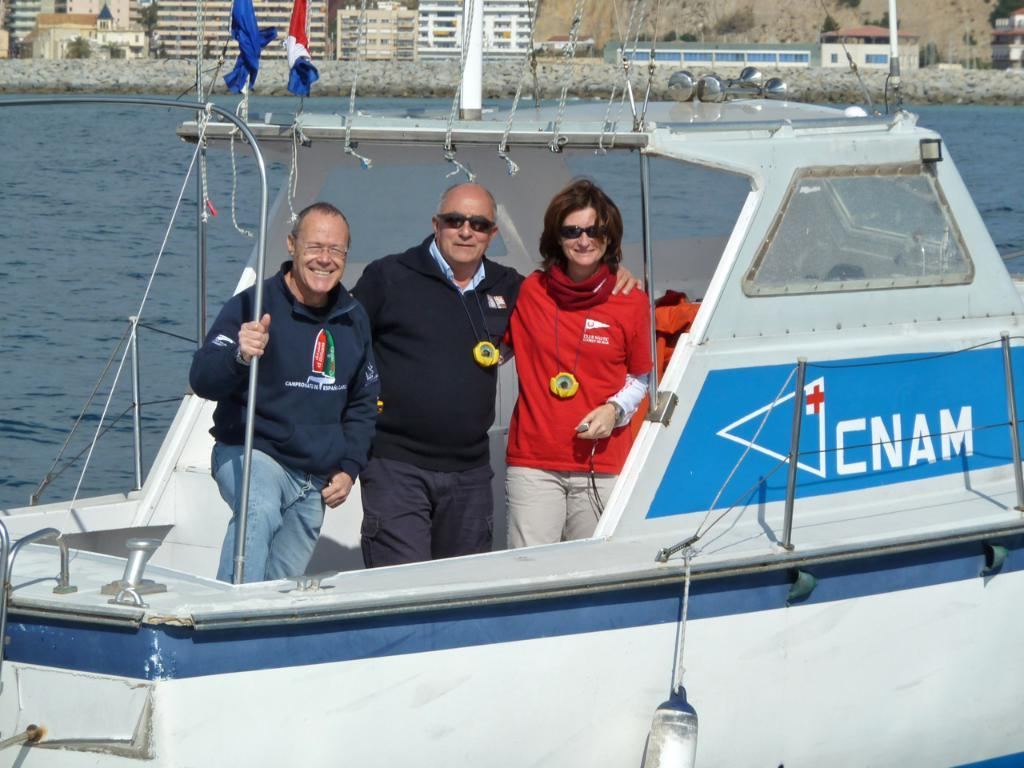<image>
Present a compact description of the photo's key features. A boat says CNAM on the side next to a blue flag picture. 